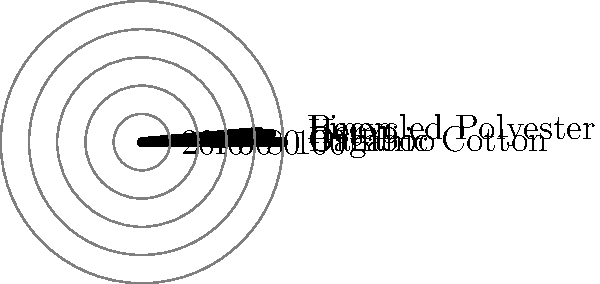Based on the polar bar chart showing the carbon footprint reduction of various eco-friendly textiles compared to conventional ones, which textile alternative offers the highest percentage of carbon footprint reduction? To determine which textile alternative offers the highest percentage of carbon footprint reduction, we need to analyze the data presented in the polar bar chart:

1. Identify the textiles represented:
   - Organic Cotton
   - Bamboo
   - Hemp
   - Recycled Polyester
   - Linen

2. Compare the length of the bars:
   - Organic Cotton: Extends to the outermost circle (60%)
   - Bamboo: Extends to about 45%
   - Hemp: Extends to about 40%
   - Recycled Polyester: Extends to about 55%
   - Linen: Extends to about 50%

3. Identify the longest bar:
   The bar representing Organic Cotton extends the furthest from the center, reaching the 60% mark.

4. Conclude:
   Organic Cotton shows the highest percentage of carbon footprint reduction compared to conventional textiles among the options presented.
Answer: Organic Cotton 